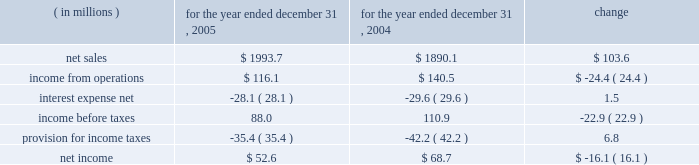Incentive compensation expense ( $ 8.2 million ) and related fringe benefit costs ( $ 1.4 million ) , and higher warehousing costs due to customer requirements ( $ 2.0 million ) .
Corporate overhead for the year ended december 31 , 2006 , increased $ 3.1 million , or 6.5% ( 6.5 % ) , from the year ended december 31 , 2005 .
The increase was primarily attributable to higher incentive compensation expense ( $ 2.6 million ) and other increased costs which were not individually significant .
Other expense , net , decreased $ 2.1 million , or 20.1% ( 20.1 % ) for the year ended december 31 , 2006 compared to the year ended december 31 , 2005 .
The decrease was primarily due to a $ 3.1 million decrease in expenses related to the disposals of property , plant and equipment as part of planned disposals in connection with capital projects .
Partially offsetting the decrease in fixed asset disposal expense was higher legal expenses ( $ 0.5 million ) and increased losses on disposals of storeroom items ( $ 0.4 million ) .
Interest expense , net and income taxes interest expense , net of interest income , increased by $ 3.1 million , or 11.1% ( 11.1 % ) , for the year ended december 31 , 2006 compared to the full year 2005 , primarily as a result of higher interest expense on our variable rate debt due to higher interest rates .
Pca 2019s effective tax rate was 35.8% ( 35.8 % ) for the year ended december 31 , 2006 and 40.2% ( 40.2 % ) for the year ended december 31 , 2005 .
The lower tax rate in 2006 is primarily due to a larger domestic manufacturer 2019s deduction and a reduction in the texas state tax rate .
For both years 2006 and 2005 , tax rates were higher than the federal statutory rate of 35.0% ( 35.0 % ) due to state income taxes .
Year ended december 31 , 2005 compared to year ended december 31 , 2004 the historical results of operations of pca for the years ended december 31 , 2005 and 2004 are set forth below : for the year ended december 31 , ( in millions ) 2005 2004 change .
Net sales net sales increased by $ 103.6 million , or 5.5% ( 5.5 % ) , for the year ended december 31 , 2005 from the year ended december 31 , 2004 .
Net sales increased primarily due to increased sales prices and volumes of corrugated products compared to 2004 .
Total corrugated products volume sold increased 4.2% ( 4.2 % ) to 31.2 billion square feet in 2005 compared to 29.9 billion square feet in 2004 .
On a comparable shipment-per-workday basis , corrugated products sales volume increased 4.6% ( 4.6 % ) in 2005 from 2004 .
Excluding pca 2019s acquisition of midland container in april 2005 , corrugated products volume was 3.0% ( 3.0 % ) higher in 2005 than 2004 and up 3.4% ( 3.4 % ) compared to 2004 on a shipment-per-workday basis .
Shipments-per-workday is calculated by dividing our total corrugated products volume during the year by the number of workdays within the year .
The larger percentage increase was due to the fact that 2005 had one less workday ( 250 days ) , those days not falling on a weekend or holiday , than 2004 ( 251 days ) .
Containerboard sales volume to external domestic and export customers decreased 12.2% ( 12.2 % ) to 417000 tons for the year ended december 31 , 2005 from 475000 tons in 2004. .
What was the operating margin for 2004? 
Computations: (140.5 / 1890.1)
Answer: 0.07433. Incentive compensation expense ( $ 8.2 million ) and related fringe benefit costs ( $ 1.4 million ) , and higher warehousing costs due to customer requirements ( $ 2.0 million ) .
Corporate overhead for the year ended december 31 , 2006 , increased $ 3.1 million , or 6.5% ( 6.5 % ) , from the year ended december 31 , 2005 .
The increase was primarily attributable to higher incentive compensation expense ( $ 2.6 million ) and other increased costs which were not individually significant .
Other expense , net , decreased $ 2.1 million , or 20.1% ( 20.1 % ) for the year ended december 31 , 2006 compared to the year ended december 31 , 2005 .
The decrease was primarily due to a $ 3.1 million decrease in expenses related to the disposals of property , plant and equipment as part of planned disposals in connection with capital projects .
Partially offsetting the decrease in fixed asset disposal expense was higher legal expenses ( $ 0.5 million ) and increased losses on disposals of storeroom items ( $ 0.4 million ) .
Interest expense , net and income taxes interest expense , net of interest income , increased by $ 3.1 million , or 11.1% ( 11.1 % ) , for the year ended december 31 , 2006 compared to the full year 2005 , primarily as a result of higher interest expense on our variable rate debt due to higher interest rates .
Pca 2019s effective tax rate was 35.8% ( 35.8 % ) for the year ended december 31 , 2006 and 40.2% ( 40.2 % ) for the year ended december 31 , 2005 .
The lower tax rate in 2006 is primarily due to a larger domestic manufacturer 2019s deduction and a reduction in the texas state tax rate .
For both years 2006 and 2005 , tax rates were higher than the federal statutory rate of 35.0% ( 35.0 % ) due to state income taxes .
Year ended december 31 , 2005 compared to year ended december 31 , 2004 the historical results of operations of pca for the years ended december 31 , 2005 and 2004 are set forth below : for the year ended december 31 , ( in millions ) 2005 2004 change .
Net sales net sales increased by $ 103.6 million , or 5.5% ( 5.5 % ) , for the year ended december 31 , 2005 from the year ended december 31 , 2004 .
Net sales increased primarily due to increased sales prices and volumes of corrugated products compared to 2004 .
Total corrugated products volume sold increased 4.2% ( 4.2 % ) to 31.2 billion square feet in 2005 compared to 29.9 billion square feet in 2004 .
On a comparable shipment-per-workday basis , corrugated products sales volume increased 4.6% ( 4.6 % ) in 2005 from 2004 .
Excluding pca 2019s acquisition of midland container in april 2005 , corrugated products volume was 3.0% ( 3.0 % ) higher in 2005 than 2004 and up 3.4% ( 3.4 % ) compared to 2004 on a shipment-per-workday basis .
Shipments-per-workday is calculated by dividing our total corrugated products volume during the year by the number of workdays within the year .
The larger percentage increase was due to the fact that 2005 had one less workday ( 250 days ) , those days not falling on a weekend or holiday , than 2004 ( 251 days ) .
Containerboard sales volume to external domestic and export customers decreased 12.2% ( 12.2 % ) to 417000 tons for the year ended december 31 , 2005 from 475000 tons in 2004. .
Income from operations was what percent of net sales for 2005? 
Computations: (116.1 / 1993.7)
Answer: 0.05823. 